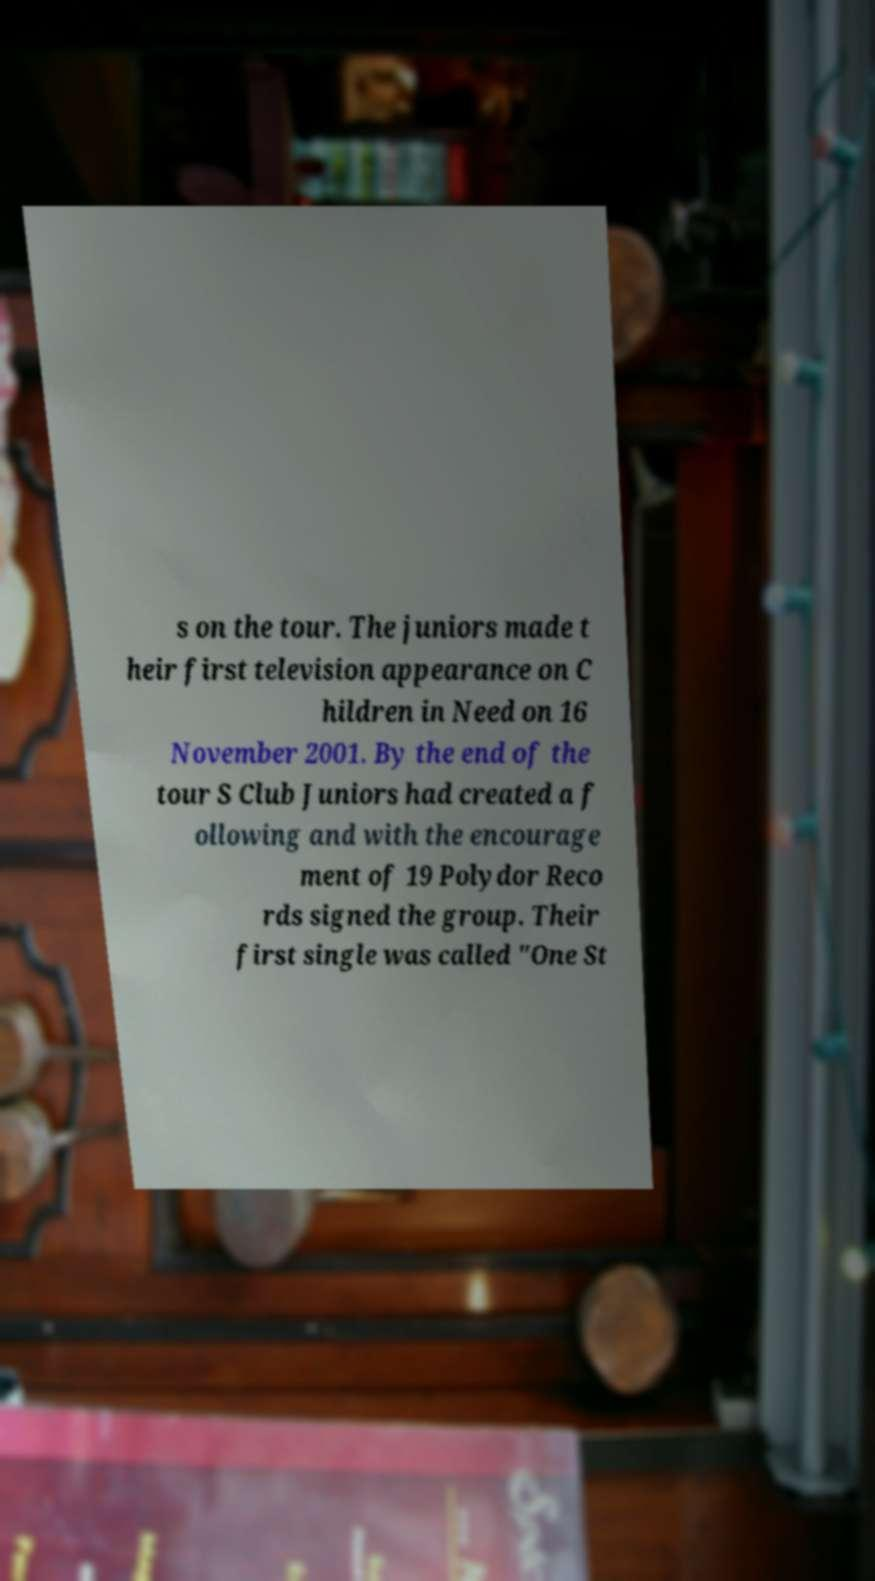Can you read and provide the text displayed in the image?This photo seems to have some interesting text. Can you extract and type it out for me? s on the tour. The juniors made t heir first television appearance on C hildren in Need on 16 November 2001. By the end of the tour S Club Juniors had created a f ollowing and with the encourage ment of 19 Polydor Reco rds signed the group. Their first single was called "One St 